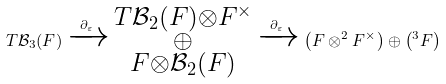<formula> <loc_0><loc_0><loc_500><loc_500>T \mathcal { B } _ { 3 } ( F ) \xrightarrow { \partial _ { \varepsilon } } \substack { T \mathcal { B } _ { 2 } ( F ) \otimes F ^ { \times } \\ \oplus \\ F \otimes \mathcal { B } _ { 2 } ( F ) } \xrightarrow { \partial _ { \varepsilon } } \left ( F \otimes ^ { 2 } F ^ { \times } \right ) \oplus \left ( ^ { 3 } F \right )</formula> 